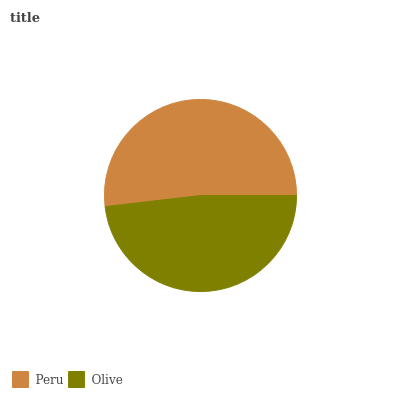Is Olive the minimum?
Answer yes or no. Yes. Is Peru the maximum?
Answer yes or no. Yes. Is Olive the maximum?
Answer yes or no. No. Is Peru greater than Olive?
Answer yes or no. Yes. Is Olive less than Peru?
Answer yes or no. Yes. Is Olive greater than Peru?
Answer yes or no. No. Is Peru less than Olive?
Answer yes or no. No. Is Peru the high median?
Answer yes or no. Yes. Is Olive the low median?
Answer yes or no. Yes. Is Olive the high median?
Answer yes or no. No. Is Peru the low median?
Answer yes or no. No. 